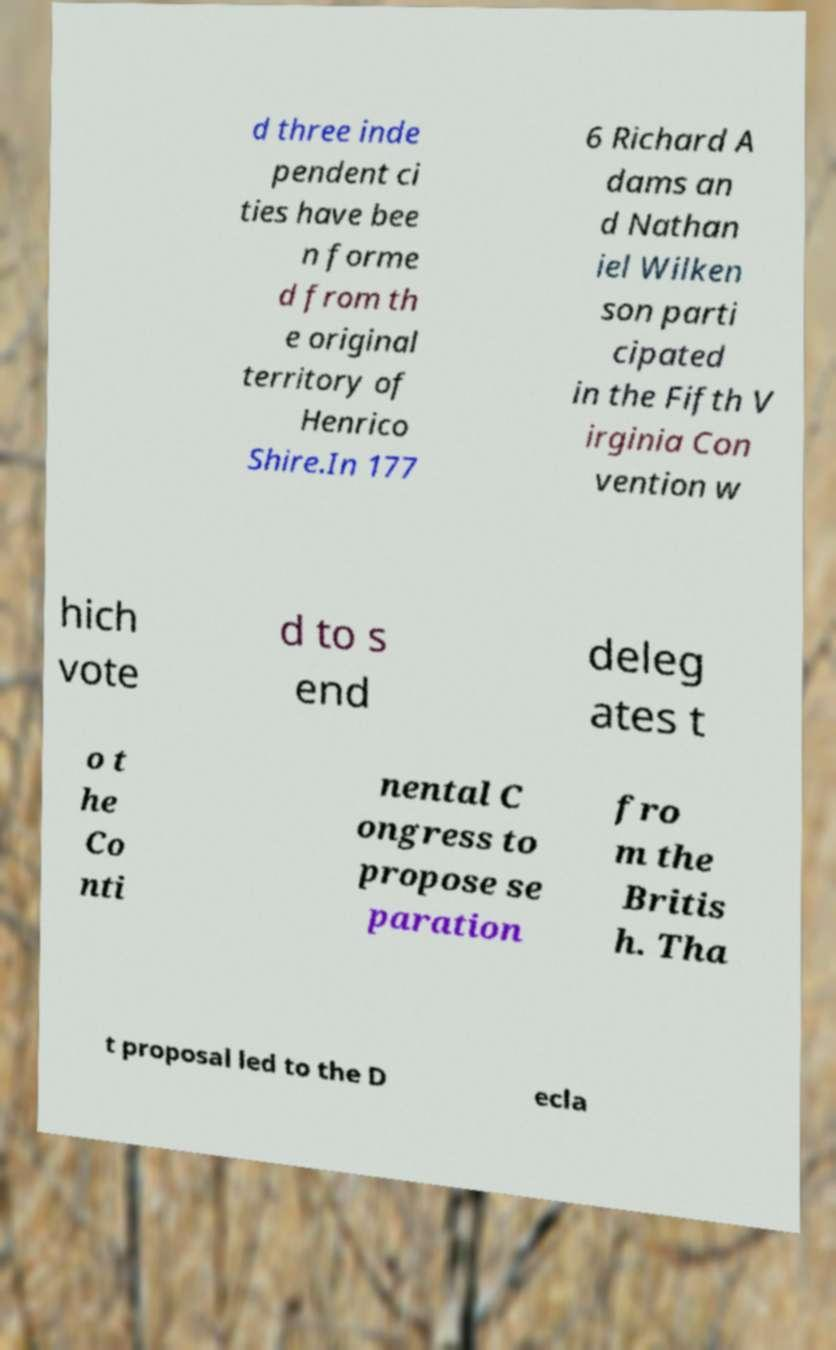Could you assist in decoding the text presented in this image and type it out clearly? d three inde pendent ci ties have bee n forme d from th e original territory of Henrico Shire.In 177 6 Richard A dams an d Nathan iel Wilken son parti cipated in the Fifth V irginia Con vention w hich vote d to s end deleg ates t o t he Co nti nental C ongress to propose se paration fro m the Britis h. Tha t proposal led to the D ecla 